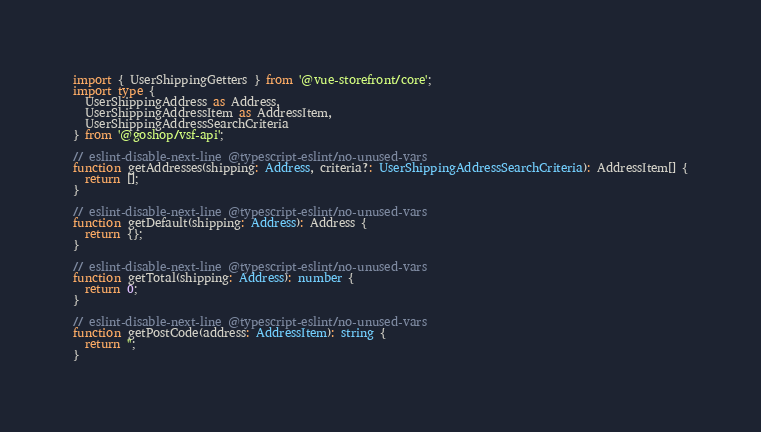Convert code to text. <code><loc_0><loc_0><loc_500><loc_500><_TypeScript_>import { UserShippingGetters } from '@vue-storefront/core';
import type {
  UserShippingAddress as Address,
  UserShippingAddressItem as AddressItem,
  UserShippingAddressSearchCriteria
} from '@goshop/vsf-api';

// eslint-disable-next-line @typescript-eslint/no-unused-vars
function getAddresses(shipping: Address, criteria?: UserShippingAddressSearchCriteria): AddressItem[] {
  return [];
}

// eslint-disable-next-line @typescript-eslint/no-unused-vars
function getDefault(shipping: Address): Address {
  return {};
}

// eslint-disable-next-line @typescript-eslint/no-unused-vars
function getTotal(shipping: Address): number {
  return 0;
}

// eslint-disable-next-line @typescript-eslint/no-unused-vars
function getPostCode(address: AddressItem): string {
  return '';
}
</code> 